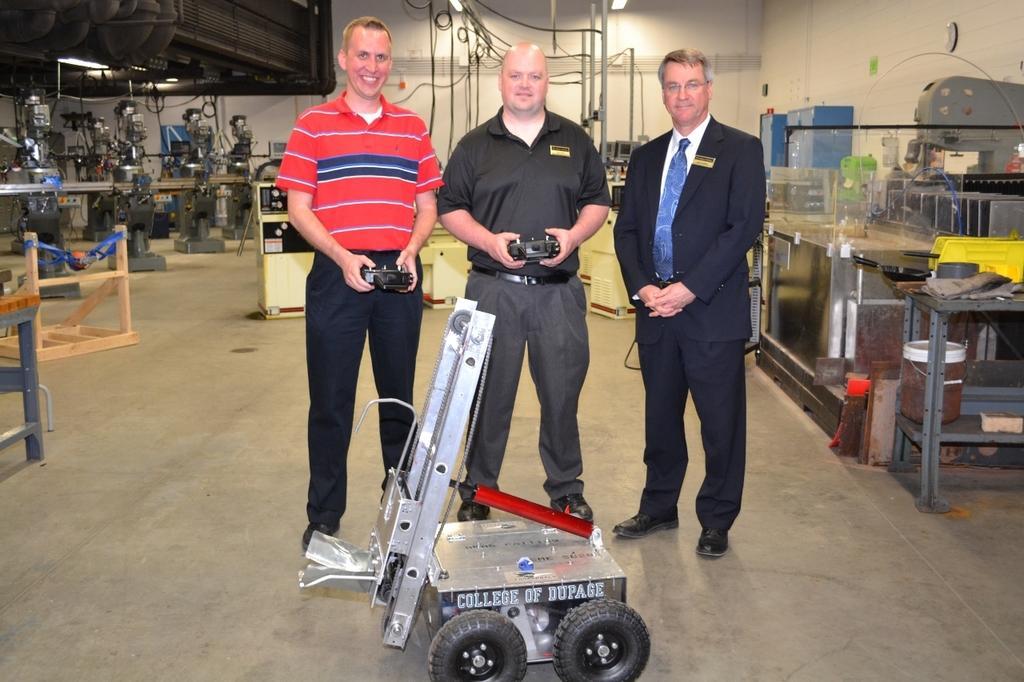Describe this image in one or two sentences. In the center of the image we can see people standing and holding remotes. At the bottom there is a trolley. In the background we can see tables and some equipment. At the top there are lights and we can see wires. There is a wall. 